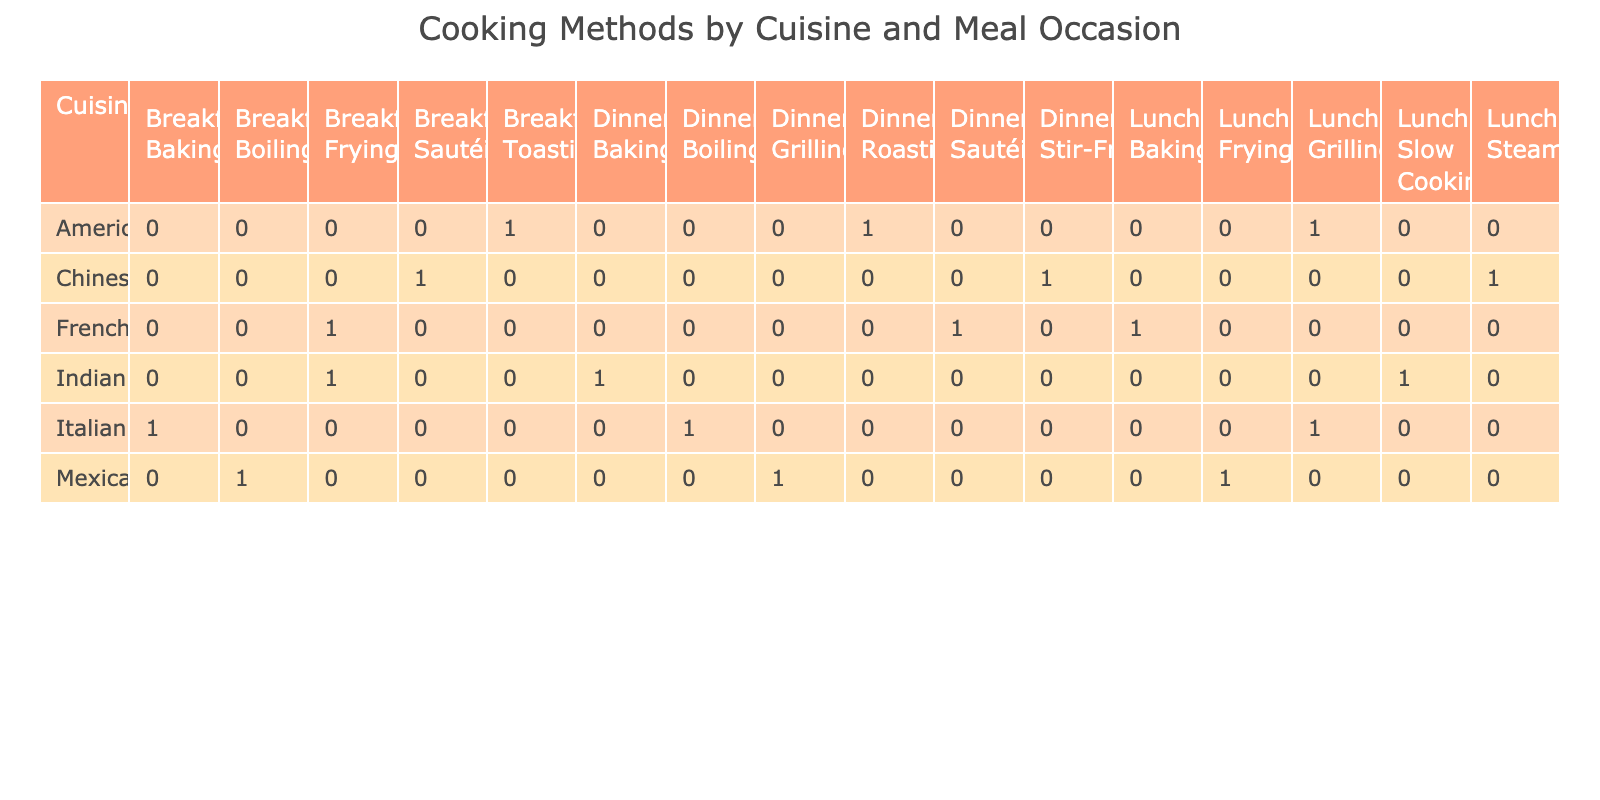What cooking method is most commonly used for Italian dinners? The table shows that “Boiling” is the only cooking method listed for Italian dinners. Therefore, it is the most commonly used method for this cuisine and occasion.
Answer: Boiling How many different cooking methods are used for lunch in Mexican cuisine? Referring to the table, Mexican cuisine for lunch shows two cooking methods: “Grilling” and “Frying.” Therefore, there are 2 different methods for lunch in this cuisine.
Answer: 2 Is frying used as a cooking method for breakfast in any cuisine listed in the table? Yes, when looking at the breakfast meal occasions, both Mexican and French cuisines utilize “Frying” as a cooking method. Therefore, the answer is yes.
Answer: Yes What is the total number of cooking methods used for dinner across all cuisines? Examining the table entries, the cooking methods for dinner across all cuisines are: Boiling, Grilling, Stir-Frying, Baking, Roasting, Sautéing. This means there are 6 different methods used for dinner overall.
Answer: 6 Which cuisine has the unique cooking method "Slow Cooking" for lunch? According to the table, "Slow Cooking" is listed exclusively under the Indian cuisine for lunch, meaning no other cuisine shares this method for this occasion.
Answer: Indian For which meal occasion is steaming used in Chinese cuisine? By checking the table, “Steaming” is specifically associated with Chinese cuisine for the lunch meal occasion. So, the answer is lunch.
Answer: Lunch Are there more baking methods used in dinner or in breakfast across all cuisines? In analyzing the table, “Baking” is used once for dinner (Italian) and once for breakfast (Indian), meaning both meal occasions have the same number (1 each). Therefore, the answer is they are equal.
Answer: Equal Which cuisine has the highest variety of cooking methods across all meal occasions? In evaluating each cuisine, the American cuisine has three different cooking methods (Dinner: Roasting, Lunch: Grilling, Breakfast: Toasting) while others have fewer. Thus, American cuisine has the highest variety of cooking methods.
Answer: American 